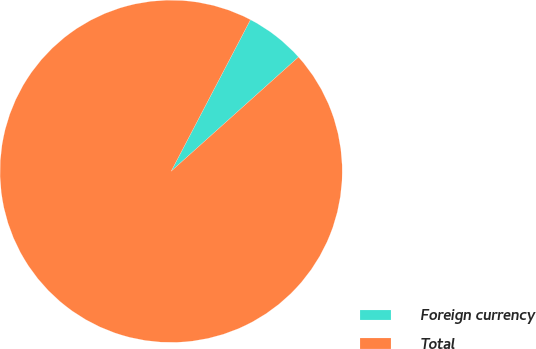<chart> <loc_0><loc_0><loc_500><loc_500><pie_chart><fcel>Foreign currency<fcel>Total<nl><fcel>5.69%<fcel>94.31%<nl></chart> 